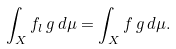<formula> <loc_0><loc_0><loc_500><loc_500>\int _ { X } f _ { l } \, g \, d \mu = \int _ { X } f \, g \, d \mu .</formula> 